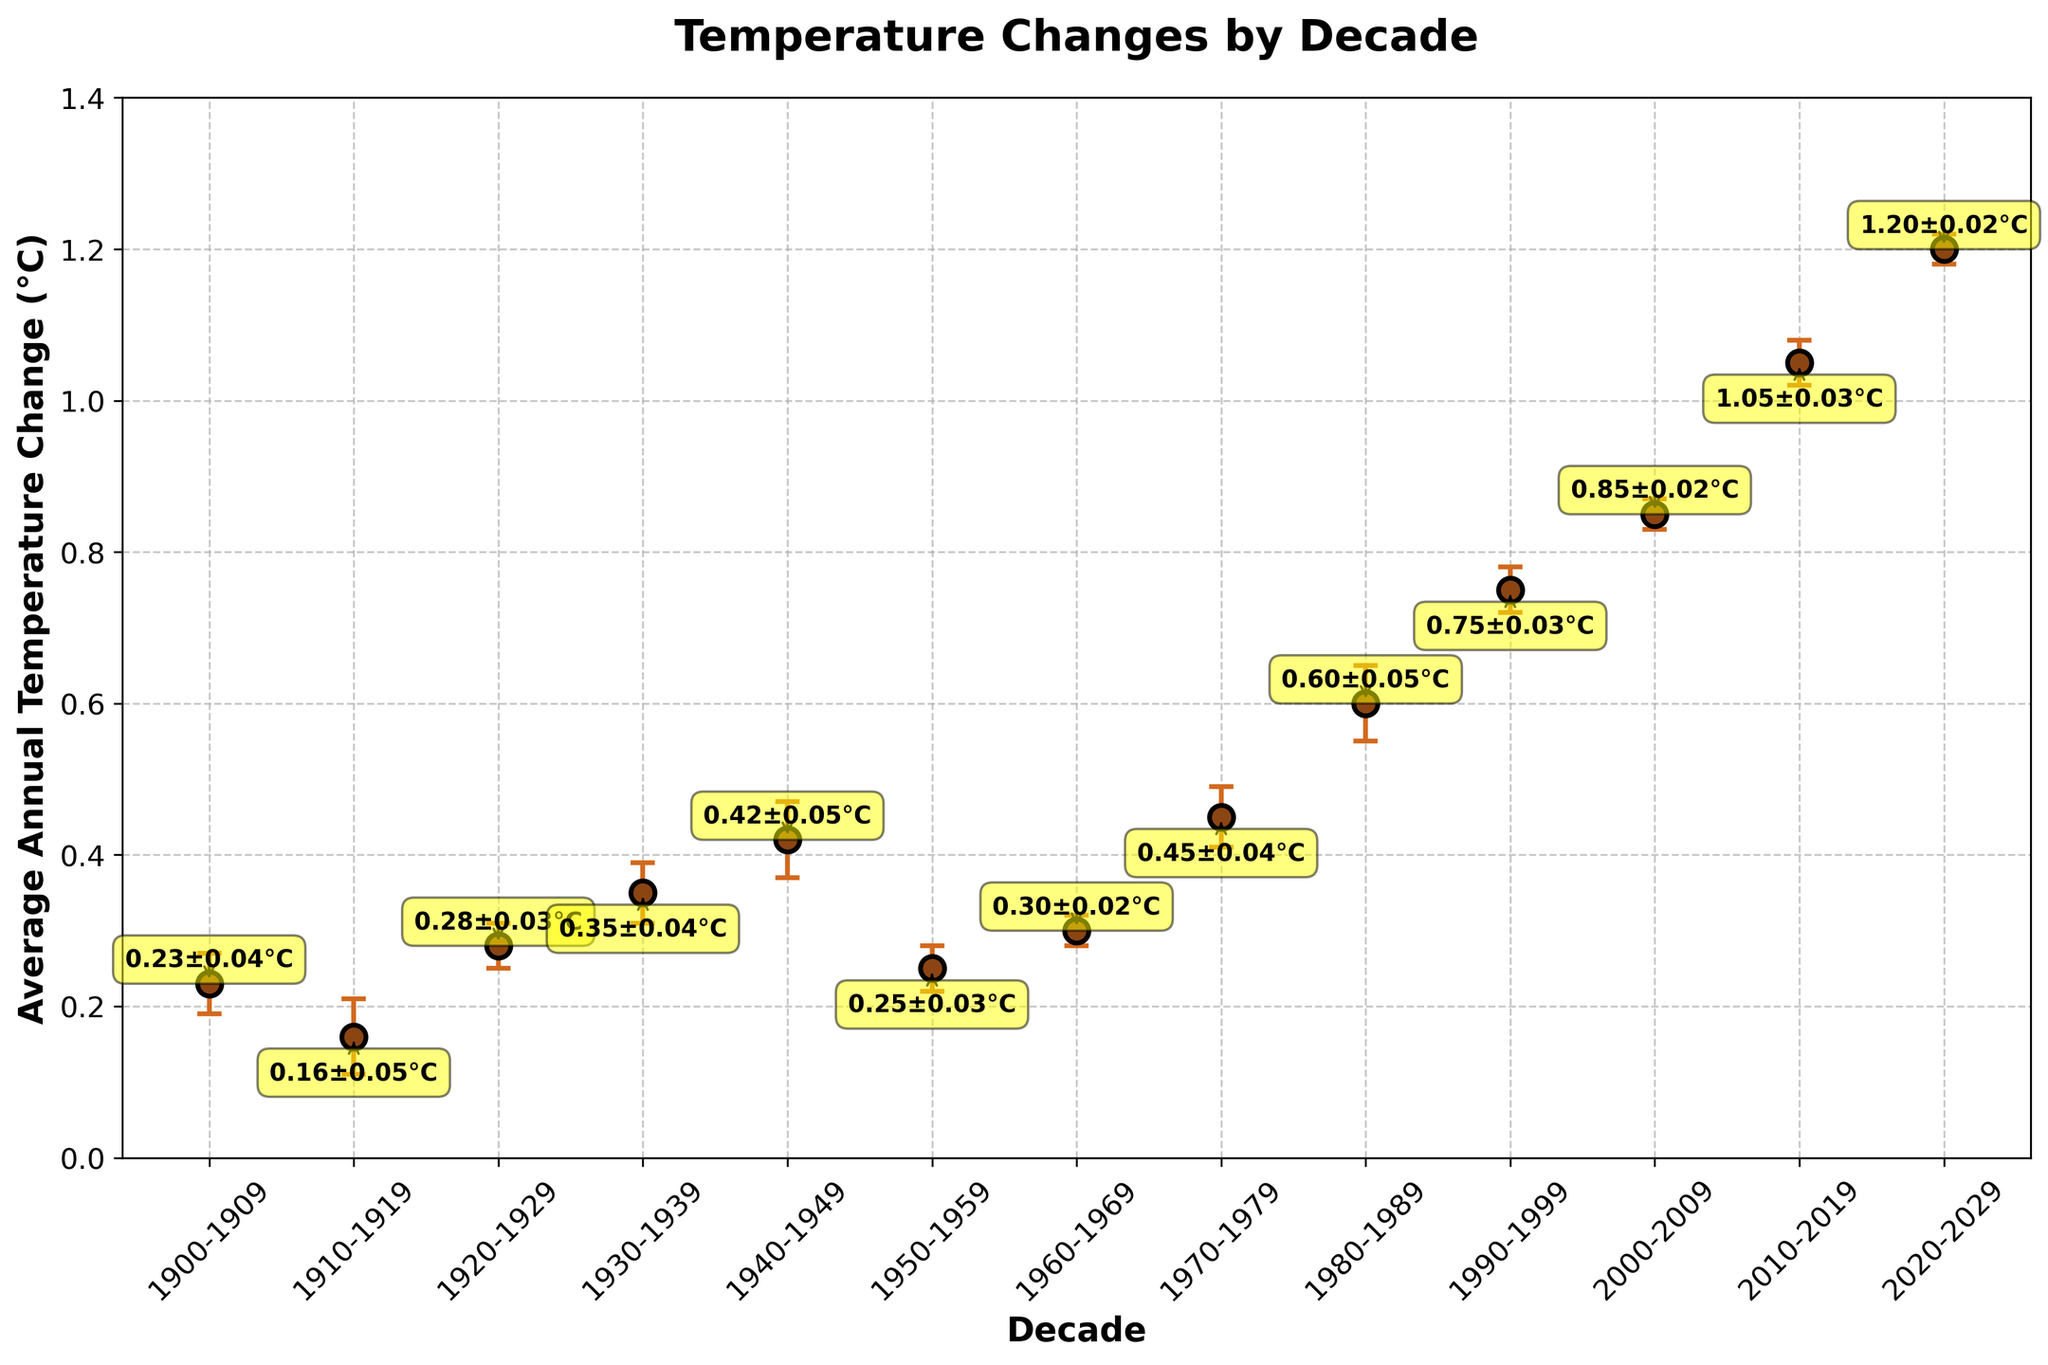What is the title of the plot? The title is typically displayed at the top of the plot. It provides a concise description of what the plot is about. In this case, it tells us that the plot illustrates temperature changes by decade.
Answer: Temperature Changes by Decade What is the average annual temperature change for the decade 1910-1919? Look at the data point corresponding to the decade 1910-1919 on the x-axis. The y-value connected to this point indicates the average annual temperature change.
Answer: 0.16°C Which decade has the highest average annual temperature change? Observe the y-values for each decade and identify the one with the highest value.
Answer: 2020-2029 What is the average margin of error for the decades provided? Add all the margin of error values and then divide by the number of decades. The sum of the margin of error values is 0.39. Dividing this by 13 (the number of decades) gives us the average margin of error.
Answer: 0.03 How does the average annual temperature change in 1930-1939 compare to 1980-1989? Compare the average annual temperature change values for the two specified decades.
Answer: The average annual temperature change is higher in 1980-1989 (0.60°C) than in 1930-1939 (0.35°C) What is the range of temperature changes across all the decades shown? Identify the minimum and maximum temperature change values and subtract the minimum from the maximum to find the range. The minimum value is 0.16, and the maximum is 1.20. Thus, the range is 1.20 - 0.16.
Answer: 1.04 What does the error bar for each data point represent? Error bars represent the margin of error for each average annual temperature change. This margin of error indicates the range within which the true value of the average annual temperature change is likely to fall.
Answer: Margin of error By how much did the average annual temperature change increase from the decade 1970-1979 to the decade 2010-2019? Subtract the average annual temperature change of 1970-1979 from that of 2010-2019. The average annual temperature change for 1970-1979 is 0.45, and for 2010-2019 it is 1.05. Thus, the increase is 1.05 - 0.45.
Answer: 0.60°C Which two consecutive decades show the largest difference in average annual temperature change? Calculate the change in average annual temperature change between each pair of consecutive decades, and identify the pair with the largest change. The largest difference is between the decades 1990-1999 and 2000-2009, where the temperature change increases from 0.75 to 0.85.
Answer: 1990-1999 to 2000-2009 